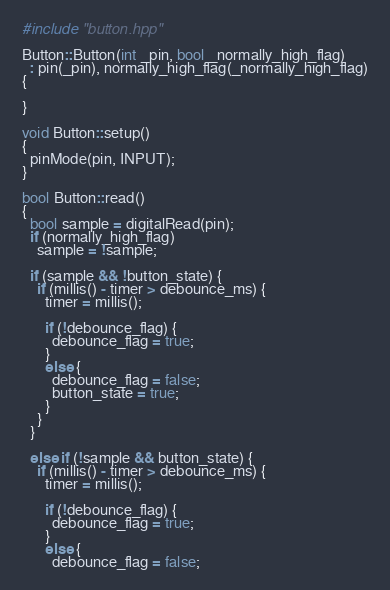Convert code to text. <code><loc_0><loc_0><loc_500><loc_500><_C++_>#include "button.hpp"

Button::Button(int _pin, bool _normally_high_flag)
  : pin(_pin), normally_high_flag(_normally_high_flag)
{

}

void Button::setup()
{
  pinMode(pin, INPUT);
}

bool Button::read()
{
  bool sample = digitalRead(pin);
  if (normally_high_flag)
    sample = !sample;

  if (sample && !button_state) {
    if (millis() - timer > debounce_ms) {
      timer = millis();

      if (!debounce_flag) {
        debounce_flag = true;
      }
      else {
        debounce_flag = false;
        button_state = true;
      }
    }
  }

  else if (!sample && button_state) {
    if (millis() - timer > debounce_ms) {
      timer = millis();

      if (!debounce_flag) {
        debounce_flag = true;
      }
      else {
        debounce_flag = false;</code> 